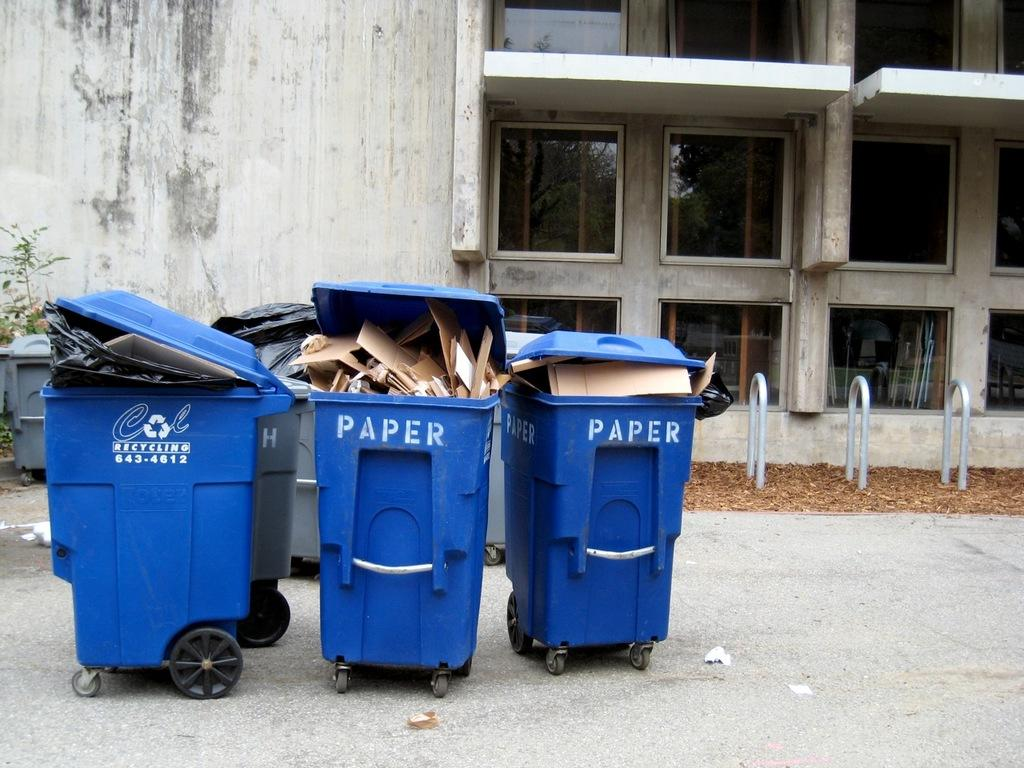<image>
Render a clear and concise summary of the photo. Three blue wheelie bins, two of which have paper written on the front. 